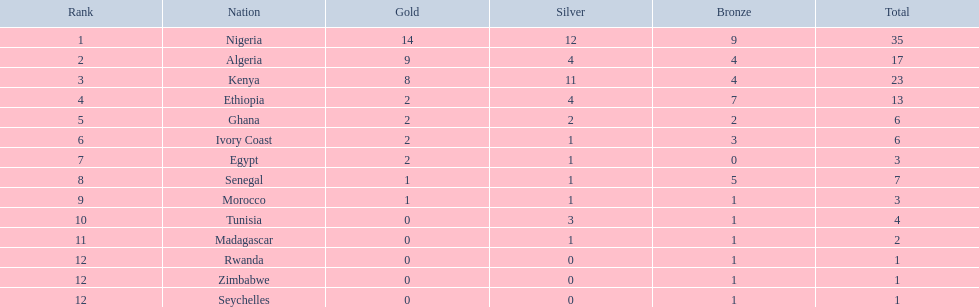Which countries participated in the 1989 african championships in athletics? Nigeria, Algeria, Kenya, Ethiopia, Ghana, Ivory Coast, Egypt, Senegal, Morocco, Tunisia, Madagascar, Rwanda, Zimbabwe, Seychelles. Among them, which secured 0 bronze medals? Egypt. 